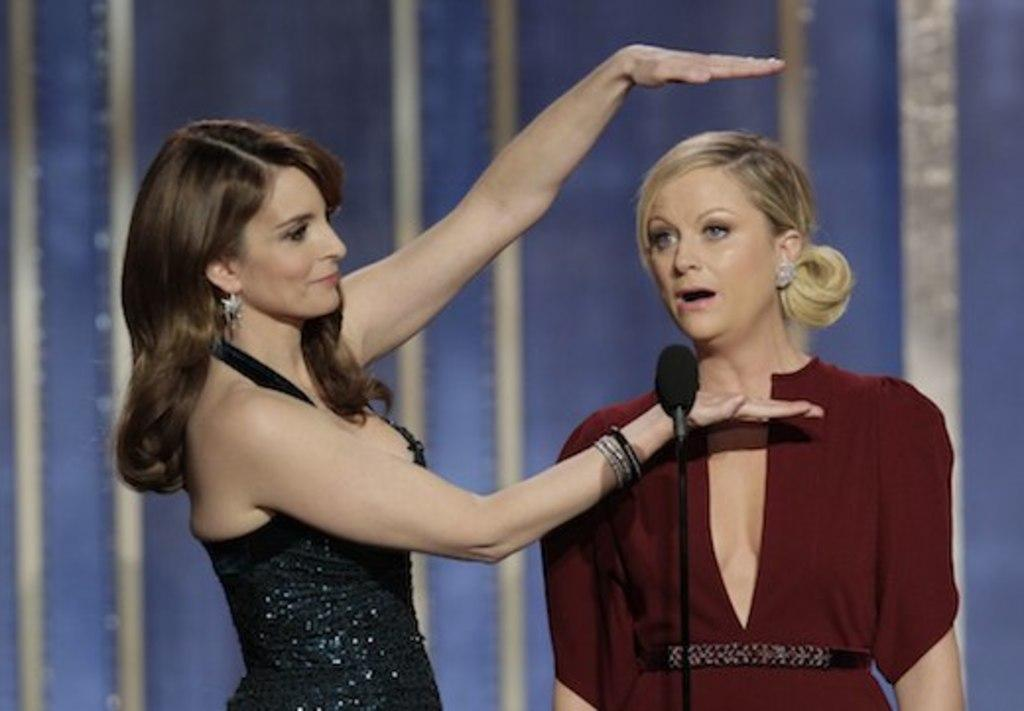How many people are present in the image? There are two people in the image. What object can be seen in the image that is typically used for amplifying sound? There is a microphone in the image. What type of covering is present in the image? There is a curtain in the image. What type of soup is being served in the image? There is no soup present in the image. What is the price of the microphone in the image? The price of the microphone is not visible in the image. 